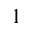<formula> <loc_0><loc_0><loc_500><loc_500>1</formula> 